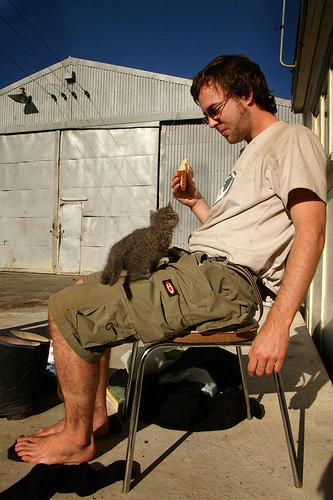Question: what color is the kitten?
Choices:
A. Black.
B. Orange and white.
C. Gray.
D. White.
Answer with the letter. Answer: C Question: why is the kitten on him?
Choices:
A. It wants to play.
B. It's hungry.
C. It needs attention.
D. It wants a toy.
Answer with the letter. Answer: B Question: who is sitting in the chair?
Choices:
A. A man.
B. A woman.
C. A boy.
D. A child.
Answer with the letter. Answer: A Question: what color is the metal building?
Choices:
A. Gray.
B. Silver.
C. Copper.
D. Brown.
Answer with the letter. Answer: B 